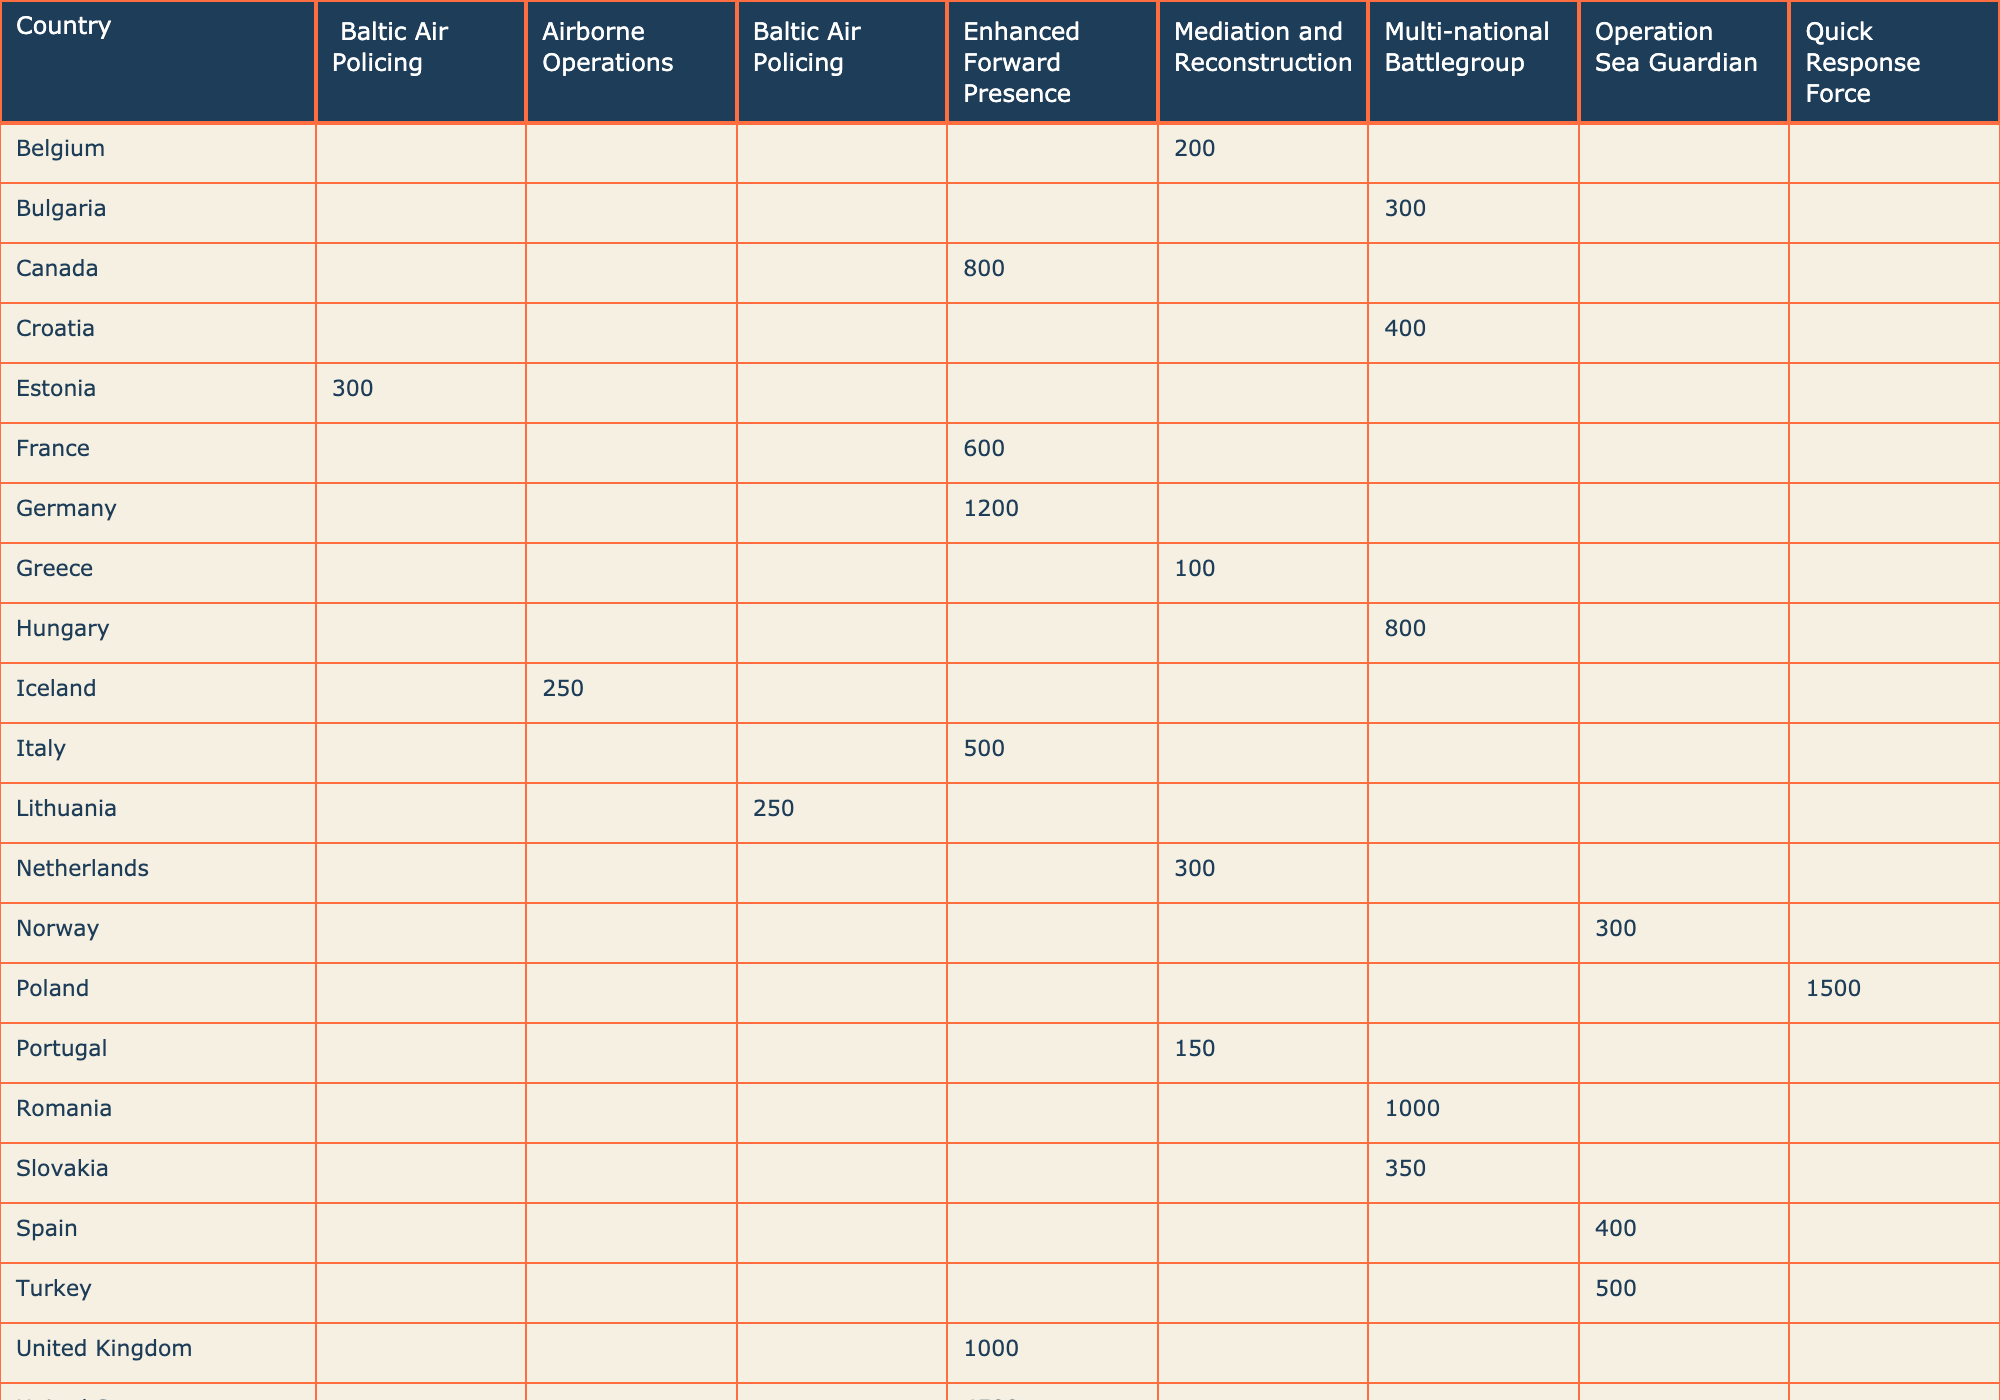What is the total number of troops deployed by the United States? The table shows that the United States has 4500 troops deployed under the Enhanced Forward Presence mission type.
Answer: 4500 Which country has the highest troop deployment for the Enhanced Forward Presence mission? The United States has the highest troop deployment for the Enhanced Forward Presence with 4500 troops, compared to Germany (1200), Canada (800), the United Kingdom (1000), France (600), and Italy (500).
Answer: United States How many troops are deployed in total for the Baltic Air Policing mission? Estonia has 300 troops and Lithuania has 250 troops, so the total is 300 + 250 = 550 troops deployed for the Baltic Air Policing mission.
Answer: 550 Is there any country with troop deployment under the Operation Sea Guardian mission that has less than 400 troops? The table shows Norway has 300 troops, which is less than 400. Therefore, the answer is yes.
Answer: Yes What is the average troop deployment for Multi-national Battlegroup countries? The countries deployed and their troop numbers are Romania (1000), Hungary (800), Croatia (400), Slovakia (350), and Bulgaria (300). The sum is 1000 + 800 + 400 + 350 + 300 = 2850. There are 5 countries, so the average is 2850 / 5 = 570.
Answer: 570 Which mission type has the lowest total troop deployment? The table shows that the Mediation and Reconstruction mission type has troop deployments of 200 (Belgium), 300 (Netherlands), 150 (Portugal), and 100 (Greece), totaling 750 troops. Other mission types have higher totals (Enhanced Forward Presence has 8620, Baltic Air Policing has 550, and others are higher). Therefore, Mediation and Reconstruction has the lowest total deployment.
Answer: Mediation and Reconstruction How many countries have deployed troops in total for Operation Sea Guardian? The countries are Spain (400), Turkey (500), and Norway (300), making a total of 3 countries that have deployed troops for this mission.
Answer: 3 Which country contributes the least number of troops to the Enhanced Forward Presence? Italy contributes the least with 500 troops compared to the other countries in the same mission type.
Answer: Italy How does the troop deployment for the Quick Response Force compare to that of the Multi-national Battlegroup? Poland has 1500 troops for the Quick Response Force, while the total for Multi-national Battlegroup is 2850 (calculated previously). Hence, 1500 is less than 2850.
Answer: Less If you sum the troop deployments for all countries under the Mediation and Reconstruction mission, what is the total? The total for Mediation and Reconstruction is 200 (Belgium) + 300 (Netherlands) + 150 (Portugal) + 100 (Greece) = 750 troops.
Answer: 750 